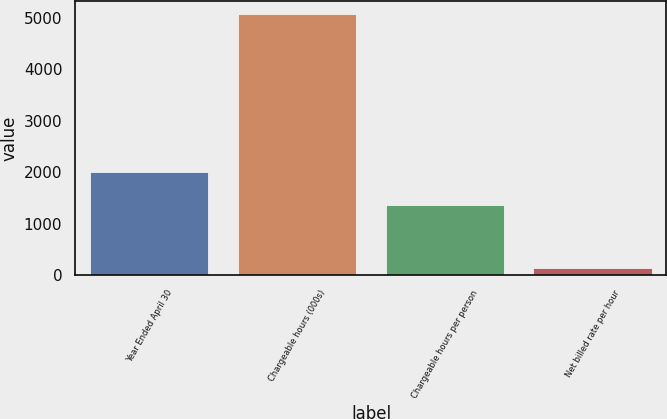Convert chart to OTSL. <chart><loc_0><loc_0><loc_500><loc_500><bar_chart><fcel>Year Ended April 30<fcel>Chargeable hours (000s)<fcel>Chargeable hours per person<fcel>Net billed rate per hour<nl><fcel>2007<fcel>5075<fcel>1373<fcel>148<nl></chart> 